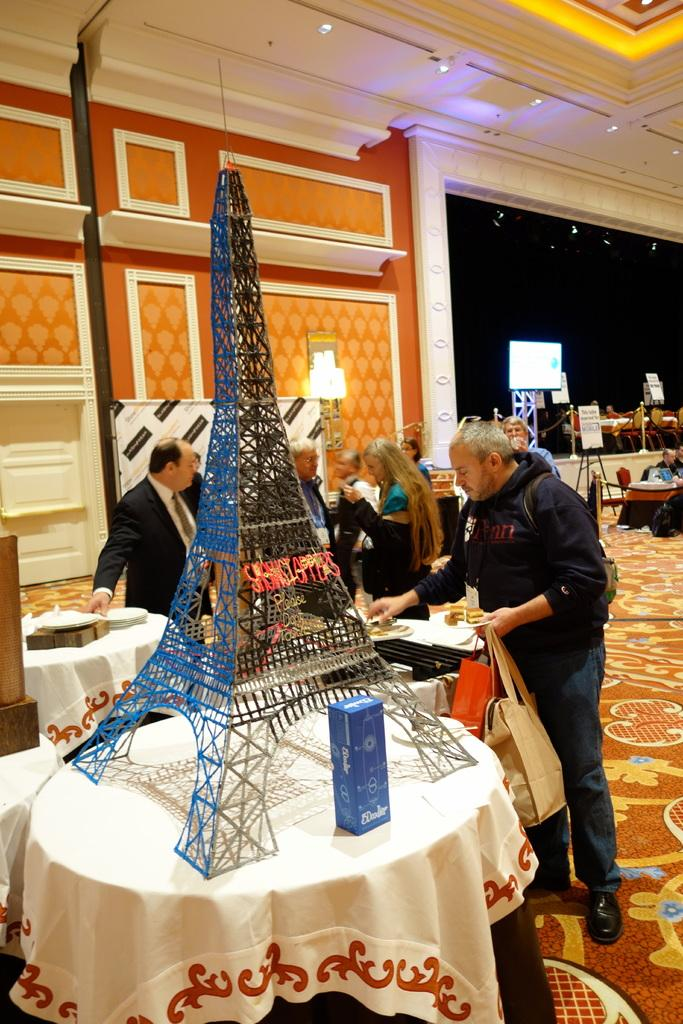How many people are in the image? There are persons in the image, but the exact number is not specified. What type of furniture is present in the image? There are tables in the image. What items can be seen related to clothing? There are clothes in the image. What type of storage containers are visible? There are boxes in the image. What architectural feature is present in the image? There is a tower in the image. What surface is visible in the image? The image shows a floor. What type of background elements can be seen? There is a wall, a screen, boards, chairs, and lights in the background of the image. Who is the owner of the yoke in the image? There is no yoke present in the image. What decisions are the committee making in the image? There is no committee present in the image. 